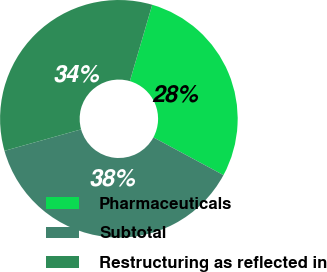Convert chart. <chart><loc_0><loc_0><loc_500><loc_500><pie_chart><fcel>Pharmaceuticals<fcel>Subtotal<fcel>Restructuring as reflected in<nl><fcel>28.34%<fcel>37.79%<fcel>33.88%<nl></chart> 